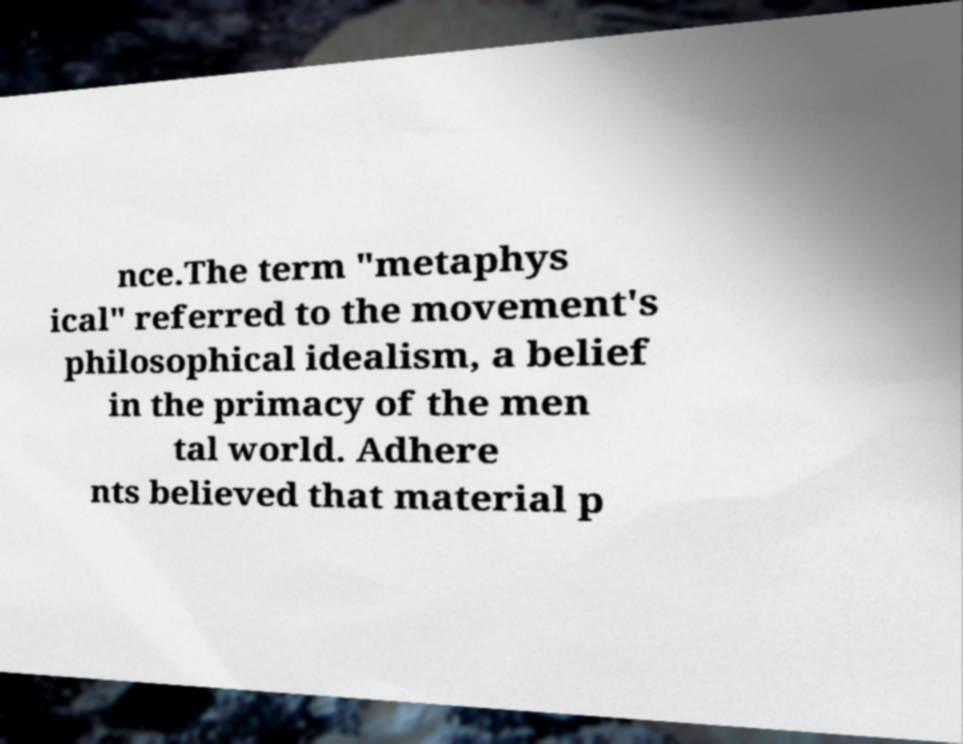I need the written content from this picture converted into text. Can you do that? nce.The term "metaphys ical" referred to the movement's philosophical idealism, a belief in the primacy of the men tal world. Adhere nts believed that material p 